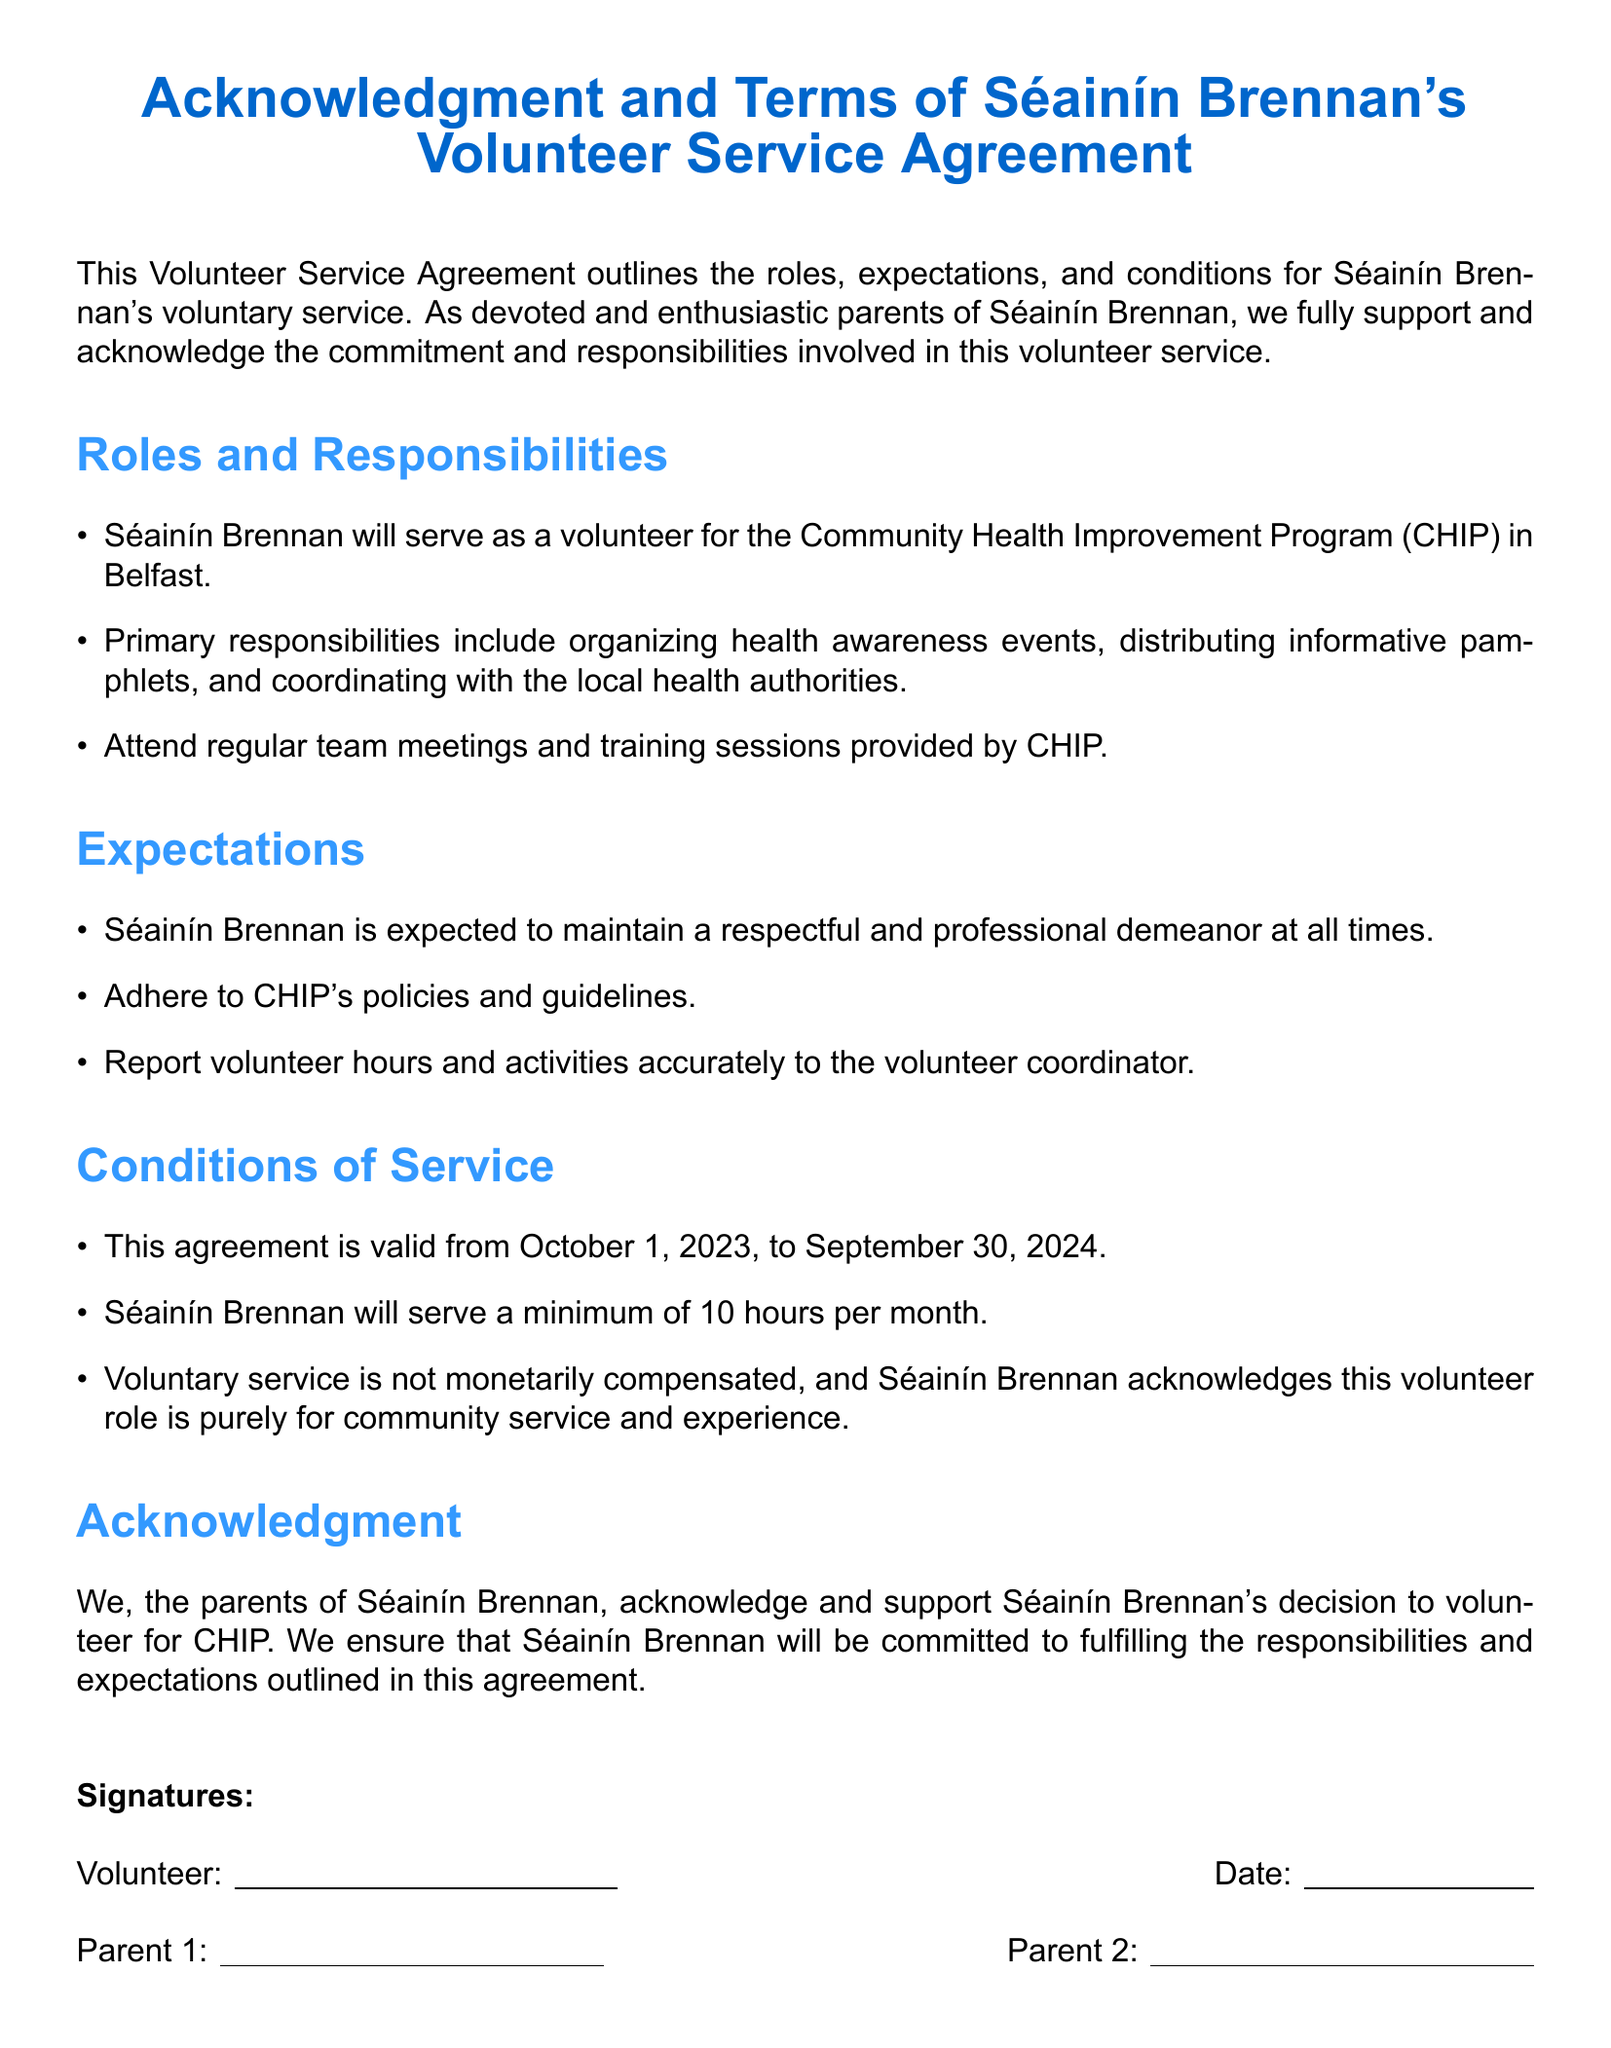What is the primary organization mentioned in the agreement? The primary organization referred to in the document is the Community Health Improvement Program (CHIP).
Answer: Community Health Improvement Program (CHIP) What is the minimum number of hours Séainín is expected to serve monthly? The document clearly states that Séainín Brennan will serve a minimum of 10 hours per month.
Answer: 10 hours What is the validity period of the agreement? The validity period of the agreement is specified from October 1, 2023, to September 30, 2024.
Answer: October 1, 2023, to September 30, 2024 What type of demeanor is Séainín expected to maintain? The document mentions that Séainín is expected to maintain a respectful and professional demeanor at all times.
Answer: Respectful and professional Is Séainín's voluntary service compensated? The document indicates that the voluntary service is not monetarily compensated.
Answer: Not compensated Who acknowledges Séainín's decision to volunteer? The document states that the parents of Séainín Brennan acknowledge and support her decision to volunteer for CHIP.
Answer: Parents What responsibilities does Séainín have regarding team meetings? Séainín is expected to attend regular team meetings and training sessions provided by CHIP.
Answer: Attend regular team meetings What is the purpose of Séainín's volunteer role? The document specifies that the volunteer role is purely for community service and experience.
Answer: Community service and experience 